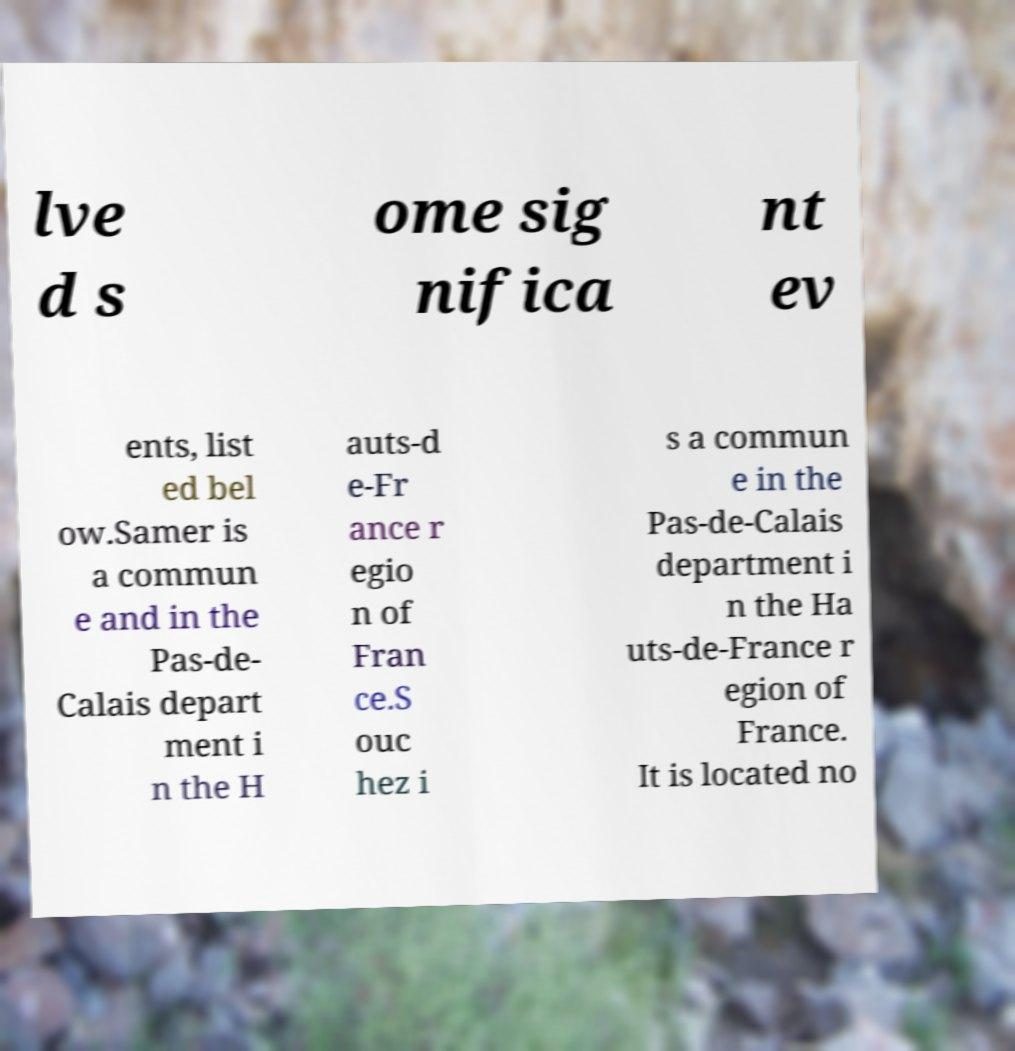Can you accurately transcribe the text from the provided image for me? lve d s ome sig nifica nt ev ents, list ed bel ow.Samer is a commun e and in the Pas-de- Calais depart ment i n the H auts-d e-Fr ance r egio n of Fran ce.S ouc hez i s a commun e in the Pas-de-Calais department i n the Ha uts-de-France r egion of France. It is located no 